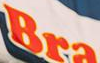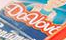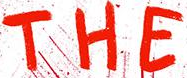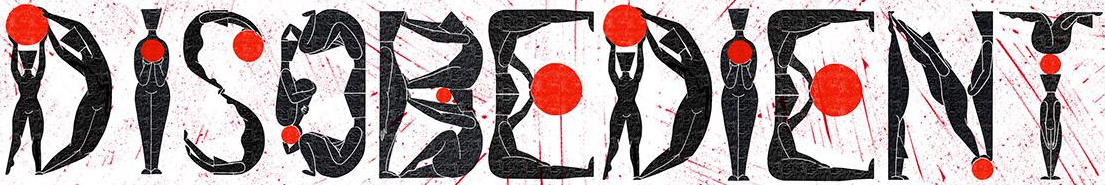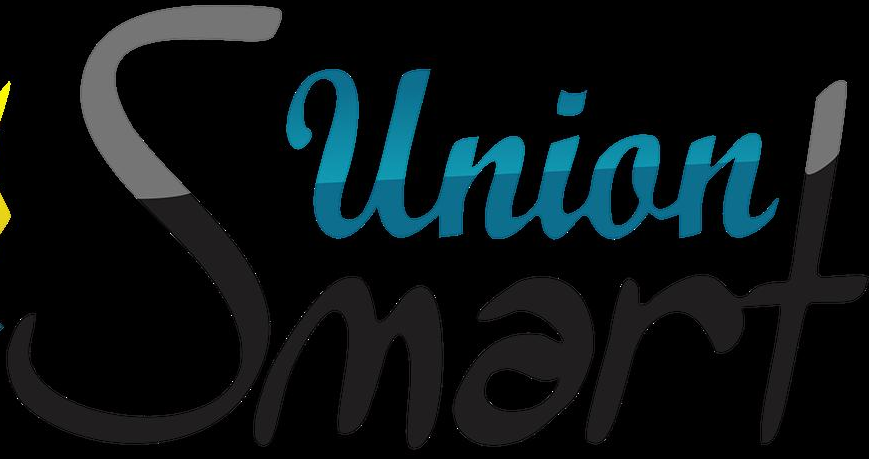Read the text from these images in sequence, separated by a semicolon. Bra; Davbv; THE; DISOBEDIENT; Smart 